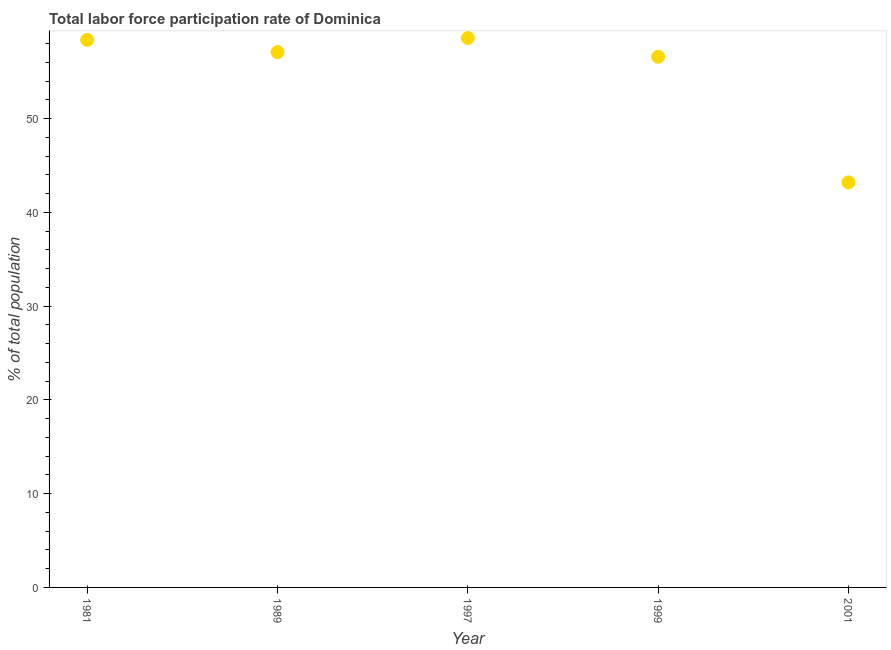What is the total labor force participation rate in 1989?
Your answer should be very brief. 57.1. Across all years, what is the maximum total labor force participation rate?
Offer a very short reply. 58.6. Across all years, what is the minimum total labor force participation rate?
Offer a terse response. 43.2. In which year was the total labor force participation rate maximum?
Offer a terse response. 1997. What is the sum of the total labor force participation rate?
Give a very brief answer. 273.9. What is the average total labor force participation rate per year?
Provide a succinct answer. 54.78. What is the median total labor force participation rate?
Give a very brief answer. 57.1. In how many years, is the total labor force participation rate greater than 18 %?
Give a very brief answer. 5. Do a majority of the years between 1981 and 1989 (inclusive) have total labor force participation rate greater than 6 %?
Offer a very short reply. Yes. What is the ratio of the total labor force participation rate in 1997 to that in 1999?
Your answer should be compact. 1.04. Is the total labor force participation rate in 1981 less than that in 1997?
Your answer should be very brief. Yes. What is the difference between the highest and the second highest total labor force participation rate?
Provide a succinct answer. 0.2. What is the difference between the highest and the lowest total labor force participation rate?
Provide a succinct answer. 15.4. In how many years, is the total labor force participation rate greater than the average total labor force participation rate taken over all years?
Keep it short and to the point. 4. Does the total labor force participation rate monotonically increase over the years?
Offer a very short reply. No. How many dotlines are there?
Make the answer very short. 1. Does the graph contain grids?
Provide a short and direct response. No. What is the title of the graph?
Give a very brief answer. Total labor force participation rate of Dominica. What is the label or title of the Y-axis?
Make the answer very short. % of total population. What is the % of total population in 1981?
Offer a terse response. 58.4. What is the % of total population in 1989?
Your response must be concise. 57.1. What is the % of total population in 1997?
Keep it short and to the point. 58.6. What is the % of total population in 1999?
Your response must be concise. 56.6. What is the % of total population in 2001?
Your answer should be compact. 43.2. What is the difference between the % of total population in 1981 and 1989?
Keep it short and to the point. 1.3. What is the difference between the % of total population in 1981 and 1999?
Provide a succinct answer. 1.8. What is the difference between the % of total population in 1989 and 1997?
Keep it short and to the point. -1.5. What is the difference between the % of total population in 1989 and 1999?
Keep it short and to the point. 0.5. What is the difference between the % of total population in 1989 and 2001?
Offer a very short reply. 13.9. What is the difference between the % of total population in 1997 and 1999?
Your answer should be compact. 2. What is the difference between the % of total population in 1999 and 2001?
Your response must be concise. 13.4. What is the ratio of the % of total population in 1981 to that in 1989?
Keep it short and to the point. 1.02. What is the ratio of the % of total population in 1981 to that in 1999?
Provide a succinct answer. 1.03. What is the ratio of the % of total population in 1981 to that in 2001?
Ensure brevity in your answer.  1.35. What is the ratio of the % of total population in 1989 to that in 1999?
Offer a very short reply. 1.01. What is the ratio of the % of total population in 1989 to that in 2001?
Your response must be concise. 1.32. What is the ratio of the % of total population in 1997 to that in 1999?
Keep it short and to the point. 1.03. What is the ratio of the % of total population in 1997 to that in 2001?
Your answer should be compact. 1.36. What is the ratio of the % of total population in 1999 to that in 2001?
Your answer should be compact. 1.31. 